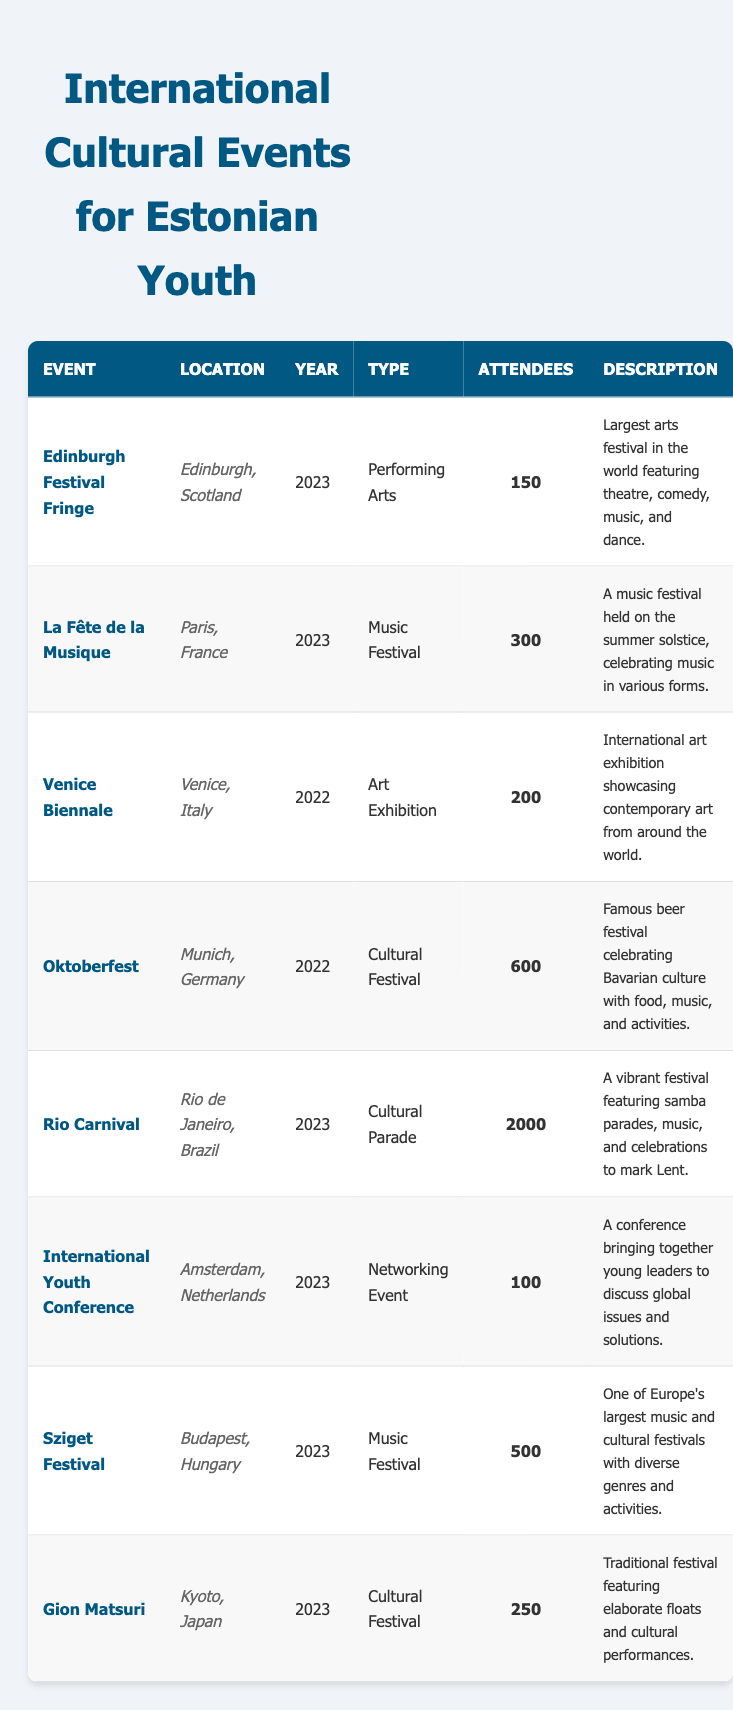What is the location of the Rio Carnival? Referring to the table, the Rio Carnival is listed under the location column, which states "Rio de Janeiro, Brazil."
Answer: Rio de Janeiro, Brazil How many attendees were at the Sziget Festival? According to the table, the Sziget Festival had 500 attendees as indicated in the attendees column.
Answer: 500 Which event had the most attendees in 2023? The Rio Carnival, with 2000 attendees, had the most attendees in 2023. By comparing the attendee numbers of all 2023 events listed, Rio Carnival stands out.
Answer: Rio Carnival Was the Gion Matsuri held in Europe? Checking the location of the Gion Matsuri in the table, it is stated to be held in Kyoto, Japan, which is not in Europe.
Answer: No What type of event is the Edinburgh Festival Fringe? The type of event for the Edinburgh Festival Fringe is specified in the table, where it is categorized as "Performing Arts."
Answer: Performing Arts What is the average number of attendees across all events listed in 2023? To find the average for 2023 events, we sum the attendees (150 + 300 + 2000 + 100 + 500 + 250 = 3300) and divide by the number of events (6). Thus, the average is 3300/6 = 550.
Answer: 550 Which event had fewer than 200 attendees? Referring to the table, only the International Youth Conference had 100 attendees, which is below 200. The other events exceed this number.
Answer: International Youth Conference Did any of the events in 2022 occur in Germany? The table shows two events from 2022. Oktoberfest, specifically listed as happening in Munich, Germany, confirms that at least one event occurred in Germany.
Answer: Yes How many cultural festivals were listed in the table? By scanning the table, we identify the events categorized as cultural festivals: Oktoberfest, Rio Carnival, and Gion Matsuri (three in total).
Answer: 3 